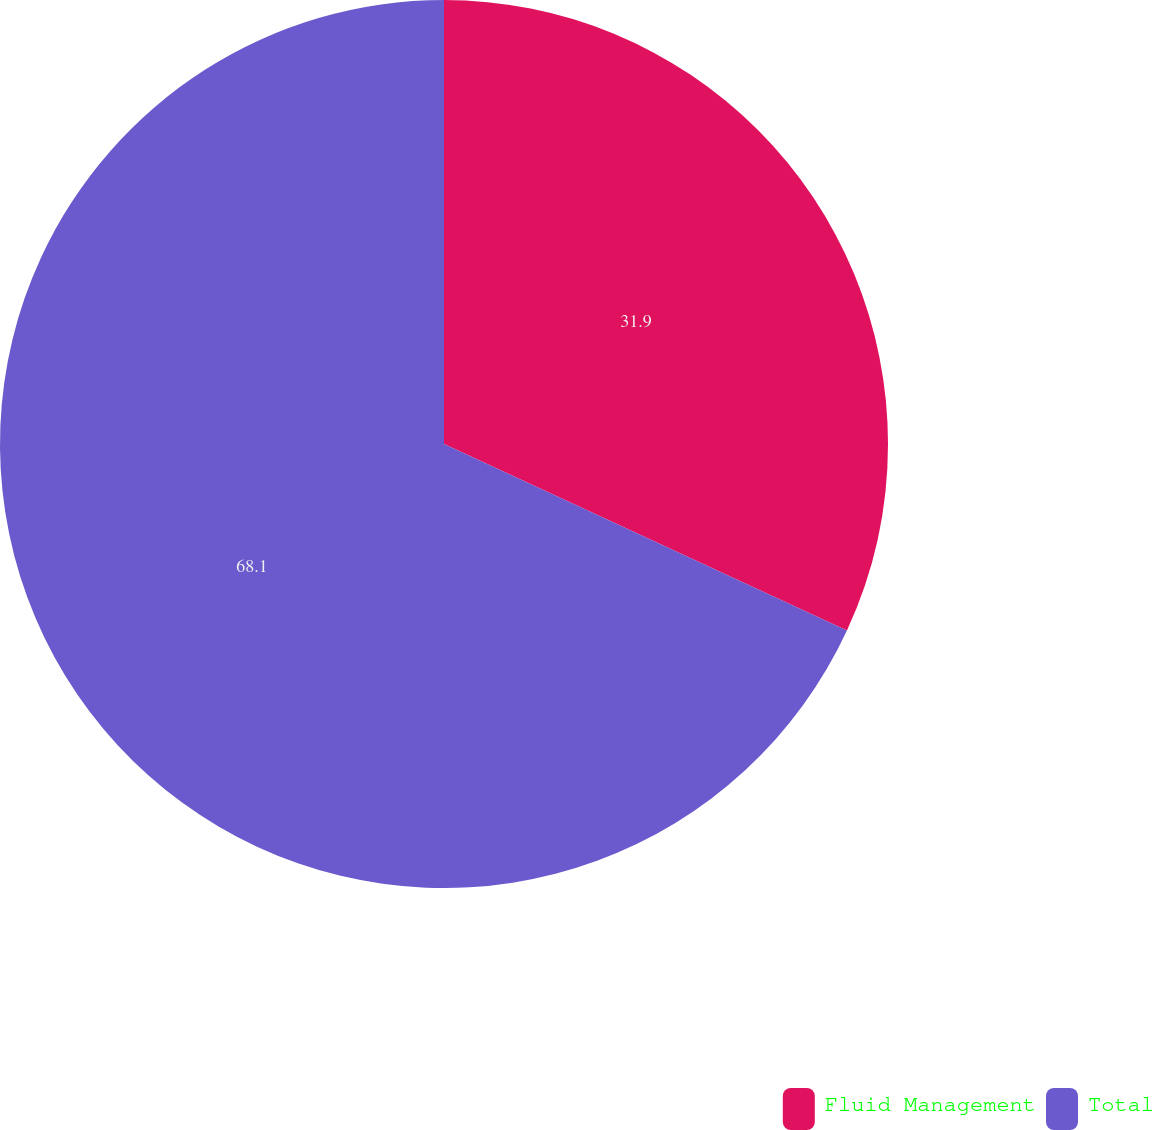Convert chart. <chart><loc_0><loc_0><loc_500><loc_500><pie_chart><fcel>Fluid Management<fcel>Total<nl><fcel>31.9%<fcel>68.1%<nl></chart> 